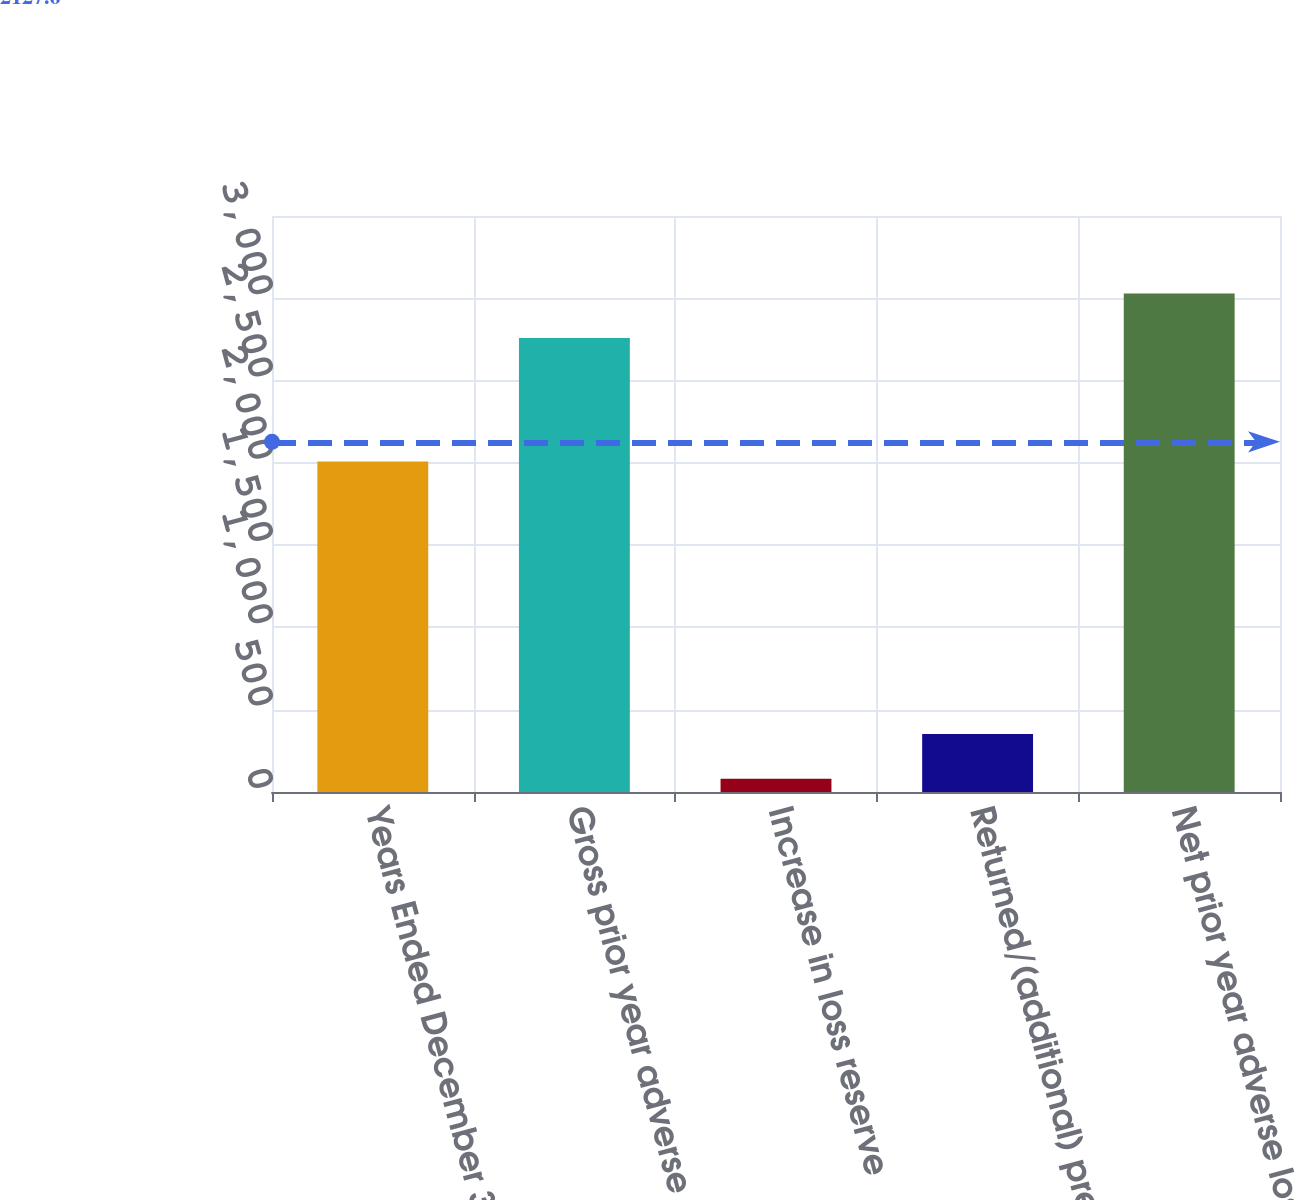Convert chart. <chart><loc_0><loc_0><loc_500><loc_500><bar_chart><fcel>Years Ended December 31 (in<fcel>Gross prior year adverse loss<fcel>Increase in loss reserve<fcel>Returned/(additional) premium<fcel>Net prior year adverse loss<nl><fcel>2009<fcel>2758<fcel>81<fcel>352.4<fcel>3029.4<nl></chart> 